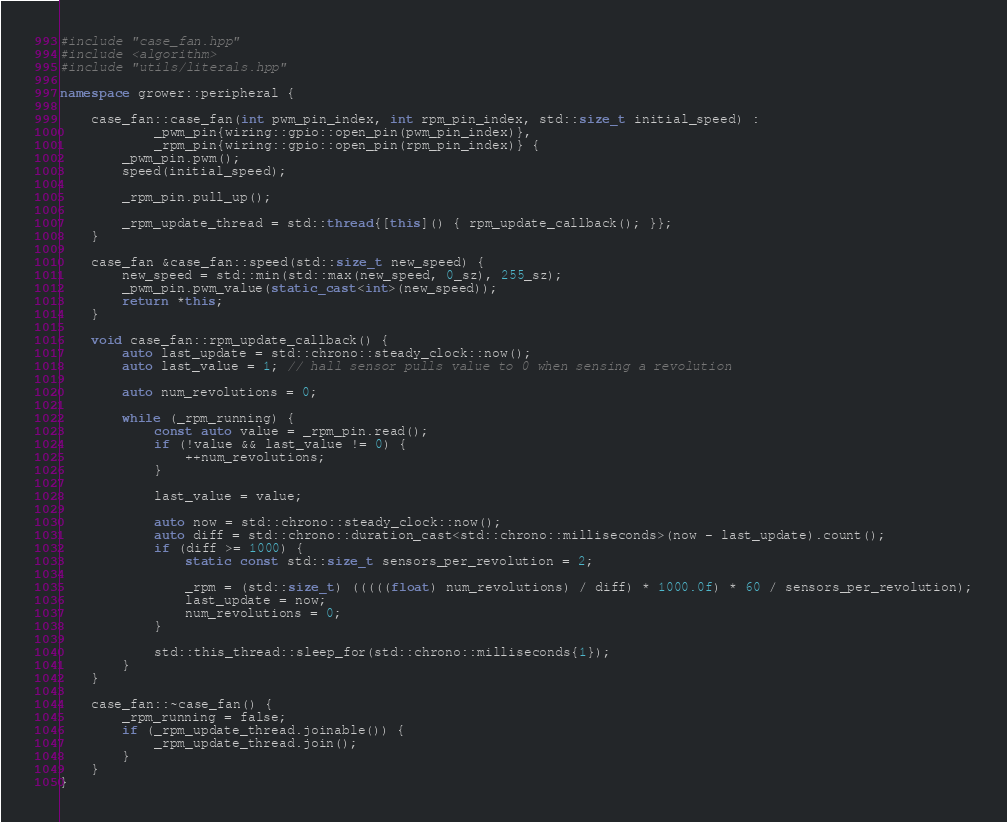<code> <loc_0><loc_0><loc_500><loc_500><_C++_>#include "case_fan.hpp"
#include <algorithm>
#include "utils/literals.hpp"

namespace grower::peripheral {

    case_fan::case_fan(int pwm_pin_index, int rpm_pin_index, std::size_t initial_speed) :
            _pwm_pin{wiring::gpio::open_pin(pwm_pin_index)},
            _rpm_pin{wiring::gpio::open_pin(rpm_pin_index)} {
        _pwm_pin.pwm();
        speed(initial_speed);

        _rpm_pin.pull_up();

        _rpm_update_thread = std::thread{[this]() { rpm_update_callback(); }};
    }

    case_fan &case_fan::speed(std::size_t new_speed) {
        new_speed = std::min(std::max(new_speed, 0_sz), 255_sz);
        _pwm_pin.pwm_value(static_cast<int>(new_speed));
        return *this;
    }

    void case_fan::rpm_update_callback() {
        auto last_update = std::chrono::steady_clock::now();
        auto last_value = 1; // hall sensor pulls value to 0 when sensing a revolution

        auto num_revolutions = 0;

        while (_rpm_running) {
            const auto value = _rpm_pin.read();
            if (!value && last_value != 0) {
                ++num_revolutions;
            }

            last_value = value;

            auto now = std::chrono::steady_clock::now();
            auto diff = std::chrono::duration_cast<std::chrono::milliseconds>(now - last_update).count();
            if (diff >= 1000) {
                static const std::size_t sensors_per_revolution = 2;

                _rpm = (std::size_t) (((((float) num_revolutions) / diff) * 1000.0f) * 60 / sensors_per_revolution);
                last_update = now;
                num_revolutions = 0;
            }

            std::this_thread::sleep_for(std::chrono::milliseconds{1});
        }
    }

    case_fan::~case_fan() {
        _rpm_running = false;
        if (_rpm_update_thread.joinable()) {
            _rpm_update_thread.join();
        }
    }
}</code> 